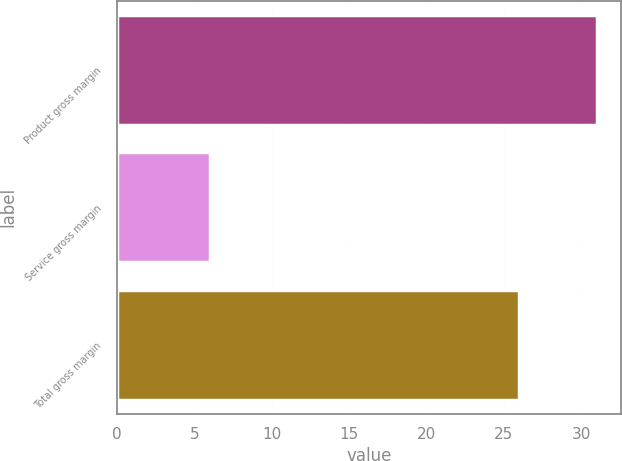Convert chart. <chart><loc_0><loc_0><loc_500><loc_500><bar_chart><fcel>Product gross margin<fcel>Service gross margin<fcel>Total gross margin<nl><fcel>31<fcel>6<fcel>26<nl></chart> 